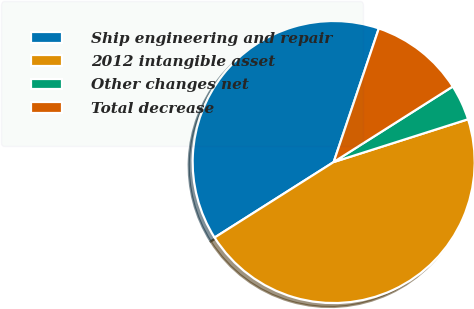Convert chart. <chart><loc_0><loc_0><loc_500><loc_500><pie_chart><fcel>Ship engineering and repair<fcel>2012 intangible asset<fcel>Other changes net<fcel>Total decrease<nl><fcel>39.18%<fcel>45.91%<fcel>4.09%<fcel>10.82%<nl></chart> 